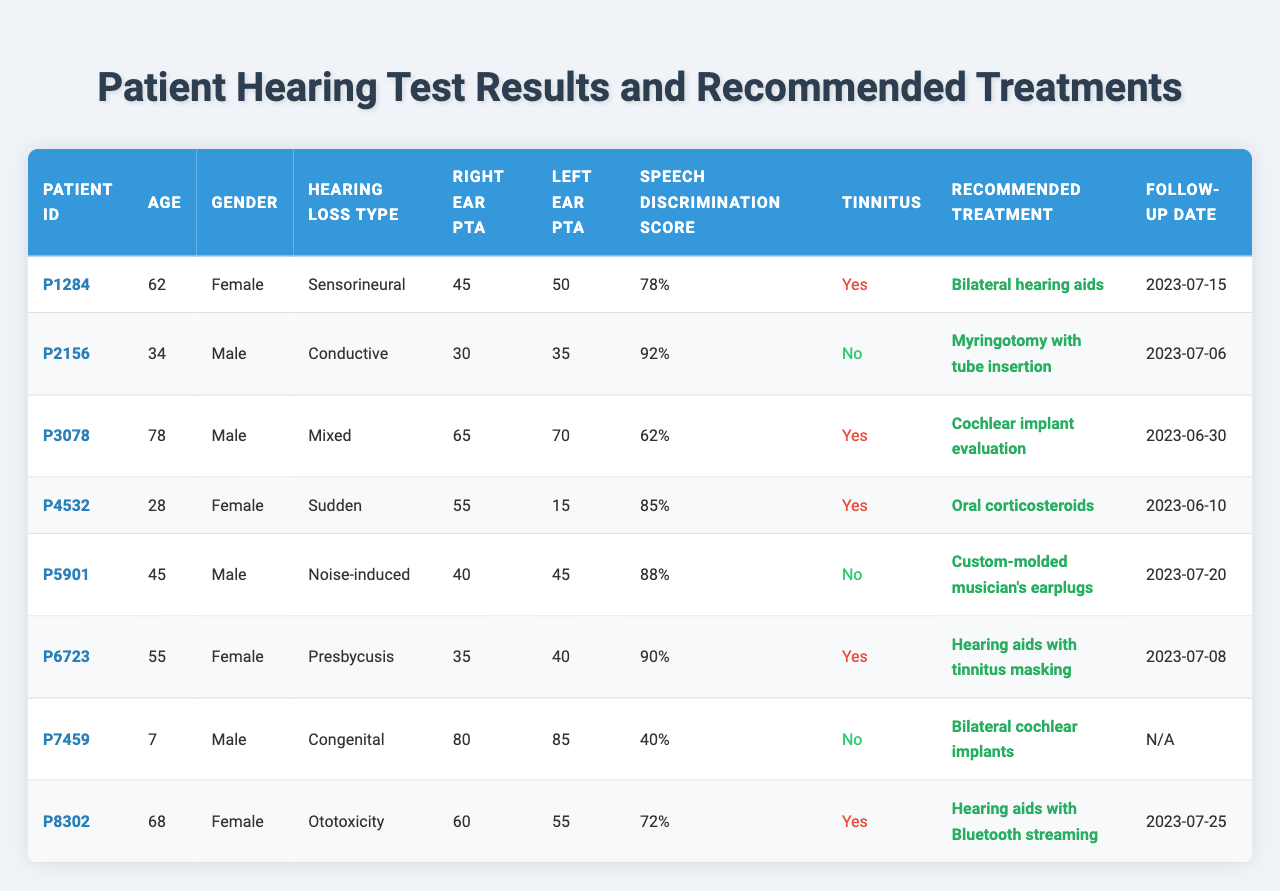What is the recommended treatment for patient P1284? The table indicates that patient P1284, who has sensorineural hearing loss, is recommended to receive "Bilateral hearing aids."
Answer: Bilateral hearing aids What is the speech discrimination score for the patient with congenital hearing loss? Referring to the table, the patient with congenital hearing loss (P7459) has a speech discrimination score of 40%.
Answer: 40% How many patients have a tinnitus condition indicated as "Yes"? By examining the table, there are four patients (P1284, P3078, P4532, and P6723) with tinnitus indicated as "Yes."
Answer: 4 Which patient recommended a cochlear implant evaluation is the oldest? Upon reviewing the data, patient P3078 is the oldest at age 78 years, and they have been recommended for a cochlear implant evaluation.
Answer: P3078 What is the difference in right ear PTA between patient P5901 and patient P6723? The right ear PTA for patient P5901 is 40, while for patient P6723 it is 35. The difference is 40 - 35 = 5.
Answer: 5 What percentage of patients recommended for hearing aids have a speech discrimination score below 80%? There are three patients recommended for hearing aids: P1284 (78%), P6723 (90%), and P8302 (72%). Only P1284 and P8302 have a score below 80%, making it 2 out of 3 patients, which is approximately 66.67%.
Answer: 66.67% Is there any patient with an age less than 30 and has a recommended treatment of oral corticosteroids? Referring to the table, patient P4532 is the only one under 30 (age 28), and they are recommended to take oral corticosteroids (Prednisone 60mg daily). Thus, the statement is true.
Answer: Yes Which patient has the highest left ear PTA and what is their recommended treatment? Patient P7459 has the highest left ear PTA at 85. They are recommended for "Bilateral cochlear implants."
Answer: P7459, Bilateral cochlear implants What is the follow-up date for the patient recommended for myringotomy? The follow-up date for patient P2156, who is recommended for myringotomy with tube insertion, is 2023-07-06, as indicated in the table.
Answer: 2023-07-06 How many patients recommended for hearing aids also report tinnitus? There are two patients recommended for hearing aids (P1284 and P6723) who also report tinnitus.
Answer: 2 What is the average right ear PTA for all patients in the table? Summing the right ear PTA values: 45 (P1284) + 30 (P2156) + 65 (P3078) + 55 (P4532) + 40 (P5901) + 35 (P6723) + 80 (P7459) + 60 (P8302) = 410. There are 8 patients, so the average is 410 / 8 = 51.25.
Answer: 51.25 